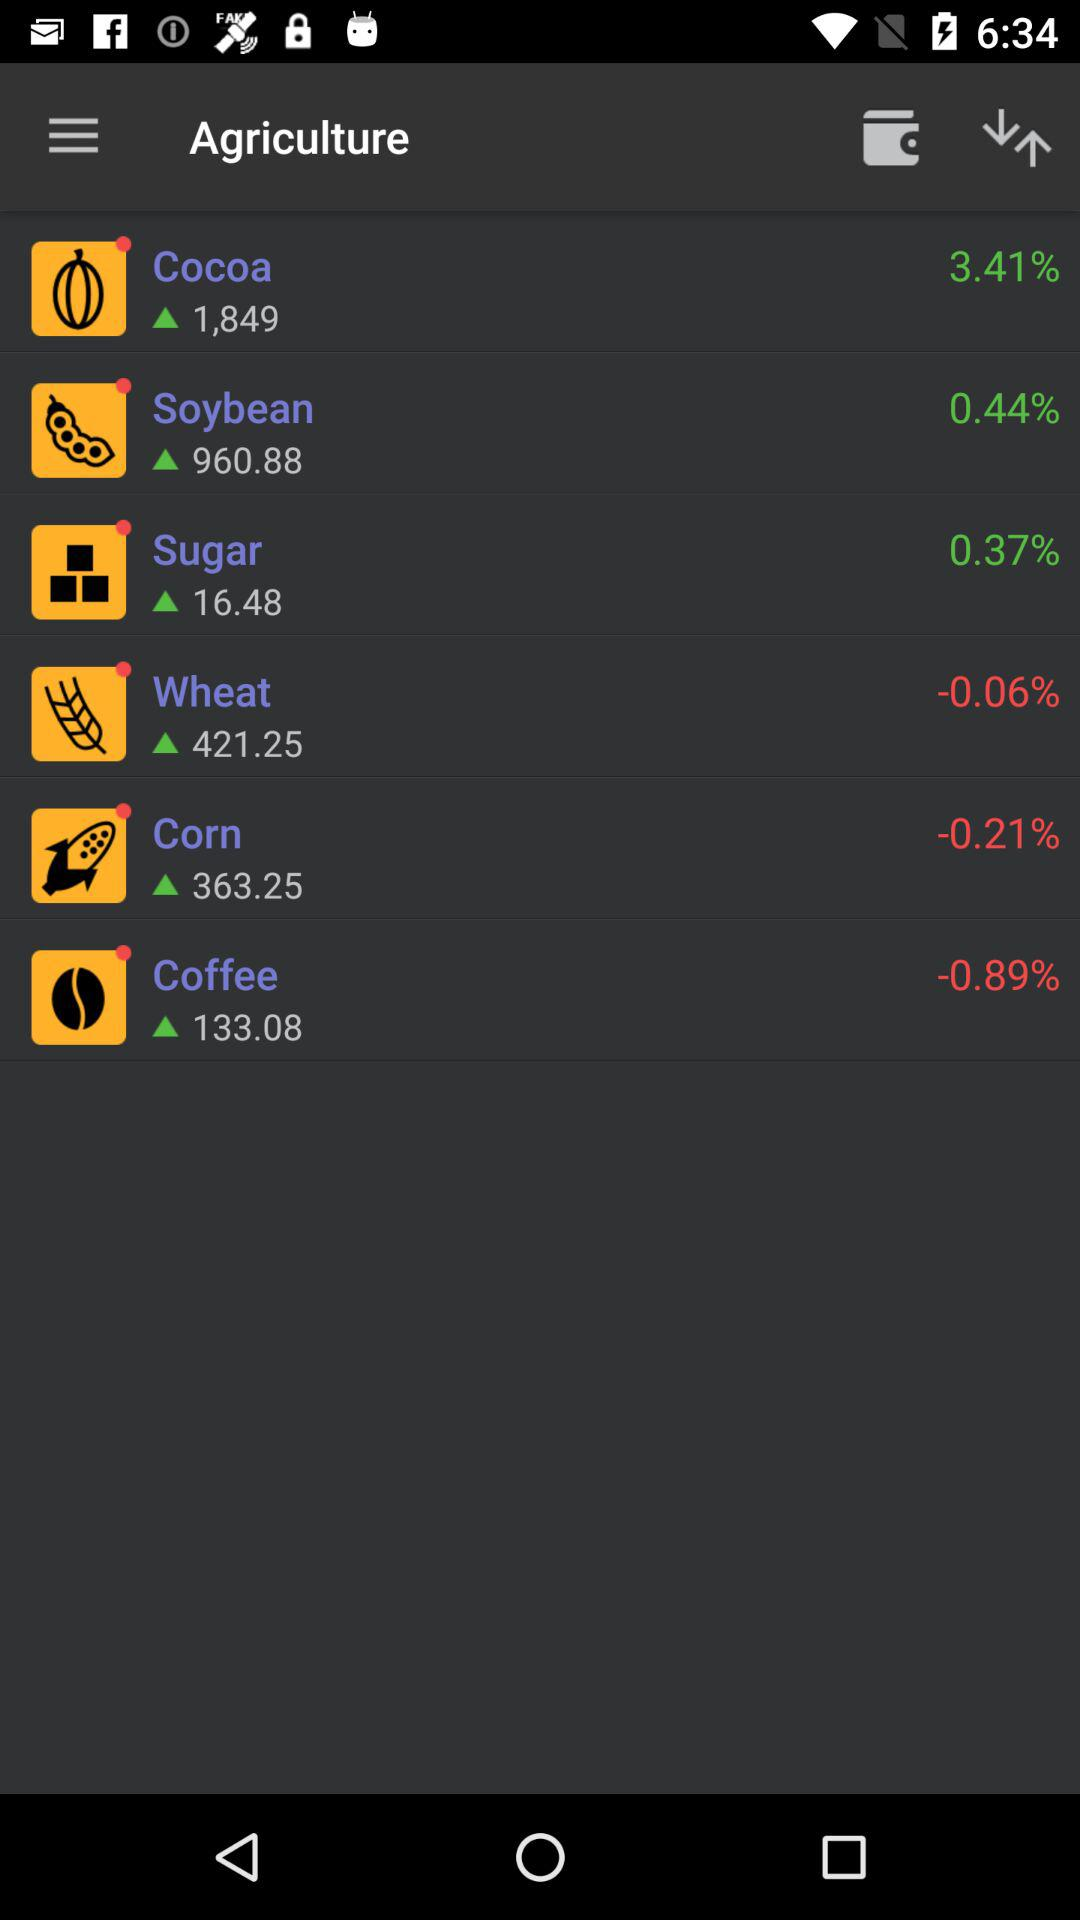What is the percentage increase in "Cocoa" production?
Answer the question using a single word or phrase. It is 3.41%. 